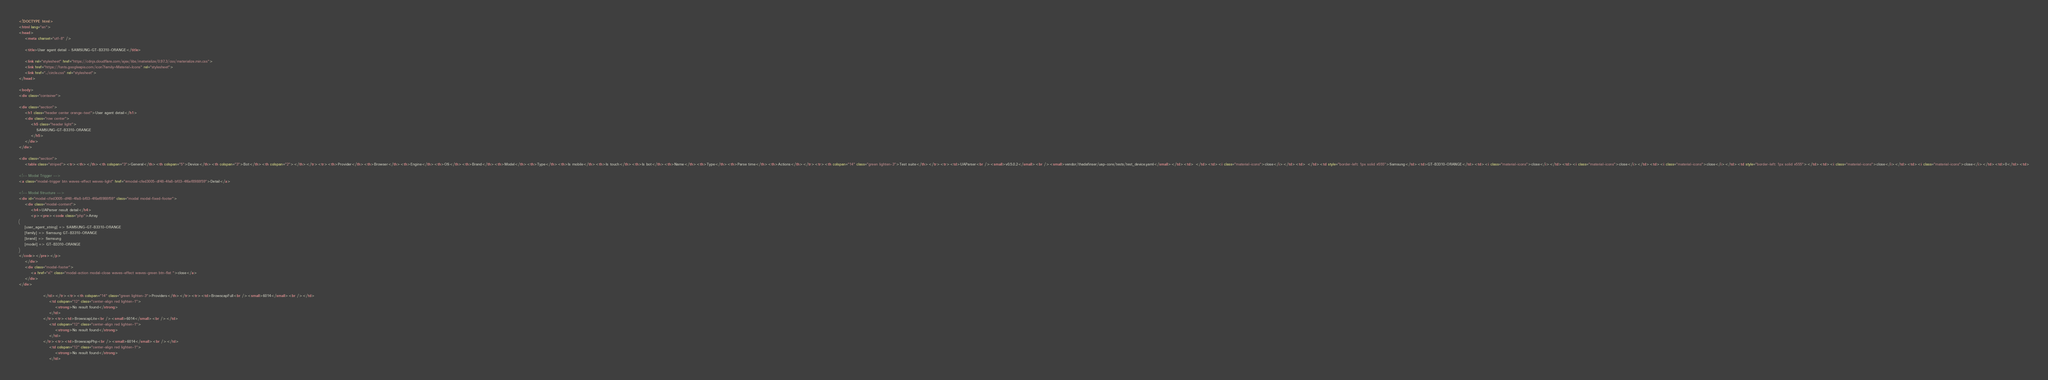Convert code to text. <code><loc_0><loc_0><loc_500><loc_500><_HTML_>
<!DOCTYPE html>
<html lang="en">
<head>
    <meta charset="utf-8" />
            
    <title>User agent detail - SAMSUNG-GT-B3310-ORANGE</title>
        
    <link rel="stylesheet" href="https://cdnjs.cloudflare.com/ajax/libs/materialize/0.97.3/css/materialize.min.css">
    <link href="https://fonts.googleapis.com/icon?family=Material+Icons" rel="stylesheet">
    <link href="../circle.css" rel="stylesheet">
</head>
        
<body>
<div class="container">
    
<div class="section">
	<h1 class="header center orange-text">User agent detail</h1>
	<div class="row center">
        <h5 class="header light">
            SAMSUNG-GT-B3310-ORANGE
        </h5>
	</div>
</div>   

<div class="section">
    <table class="striped"><tr><th></th><th colspan="3">General</th><th colspan="5">Device</th><th colspan="3">Bot</th><th colspan="2"></th></tr><tr><th>Provider</th><th>Browser</th><th>Engine</th><th>OS</th><th>Brand</th><th>Model</th><th>Type</th><th>Is mobile</th><th>Is touch</th><th>Is bot</th><th>Name</th><th>Type</th><th>Parse time</th><th>Actions</th></tr><tr><th colspan="14" class="green lighten-3">Test suite</th></tr><tr><td>UAParser<br /><small>v0.5.0.2</small><br /><small>vendor/thadafinser/uap-core/tests/test_device.yaml</small></td><td> </td><td><i class="material-icons">close</i></td><td> </td><td style="border-left: 1px solid #555">Samsung</td><td>GT-B3310-ORANGE</td><td><i class="material-icons">close</i></td><td><i class="material-icons">close</i></td><td><i class="material-icons">close</i></td><td style="border-left: 1px solid #555"></td><td><i class="material-icons">close</i></td><td><i class="material-icons">close</i></td><td>0</td><td>
        
<!-- Modal Trigger -->
<a class="modal-trigger btn waves-effect waves-light" href="#modal-cfed3005-df48-4fa8-bf03-4f6ef8988f59">Detail</a>
        
<!-- Modal Structure -->
<div id="modal-cfed3005-df48-4fa8-bf03-4f6ef8988f59" class="modal modal-fixed-footer">
    <div class="modal-content">
        <h4>UAParser result detail</h4>
        <p><pre><code class="php">Array
(
    [user_agent_string] => SAMSUNG-GT-B3310-ORANGE
    [family] => Samsung GT-B3310-ORANGE
    [brand] => Samsung
    [model] => GT-B3310-ORANGE
)
</code></pre></p>
    </div>
    <div class="modal-footer">
        <a href="#!" class="modal-action modal-close waves-effect waves-green btn-flat ">close</a>
    </div>
</div>
        
                </td></tr><tr><th colspan="14" class="green lighten-3">Providers</th></tr><tr><td>BrowscapFull<br /><small>6014</small><br /></td>
                    <td colspan="12" class="center-align red lighten-1">
                        <strong>No result found</strong>
                    </td>
                </tr><tr><td>BrowscapLite<br /><small>6014</small><br /></td>
                    <td colspan="12" class="center-align red lighten-1">
                        <strong>No result found</strong>
                    </td>
                </tr><tr><td>BrowscapPhp<br /><small>6014</small><br /></td>
                    <td colspan="12" class="center-align red lighten-1">
                        <strong>No result found</strong>
                    </td></code> 